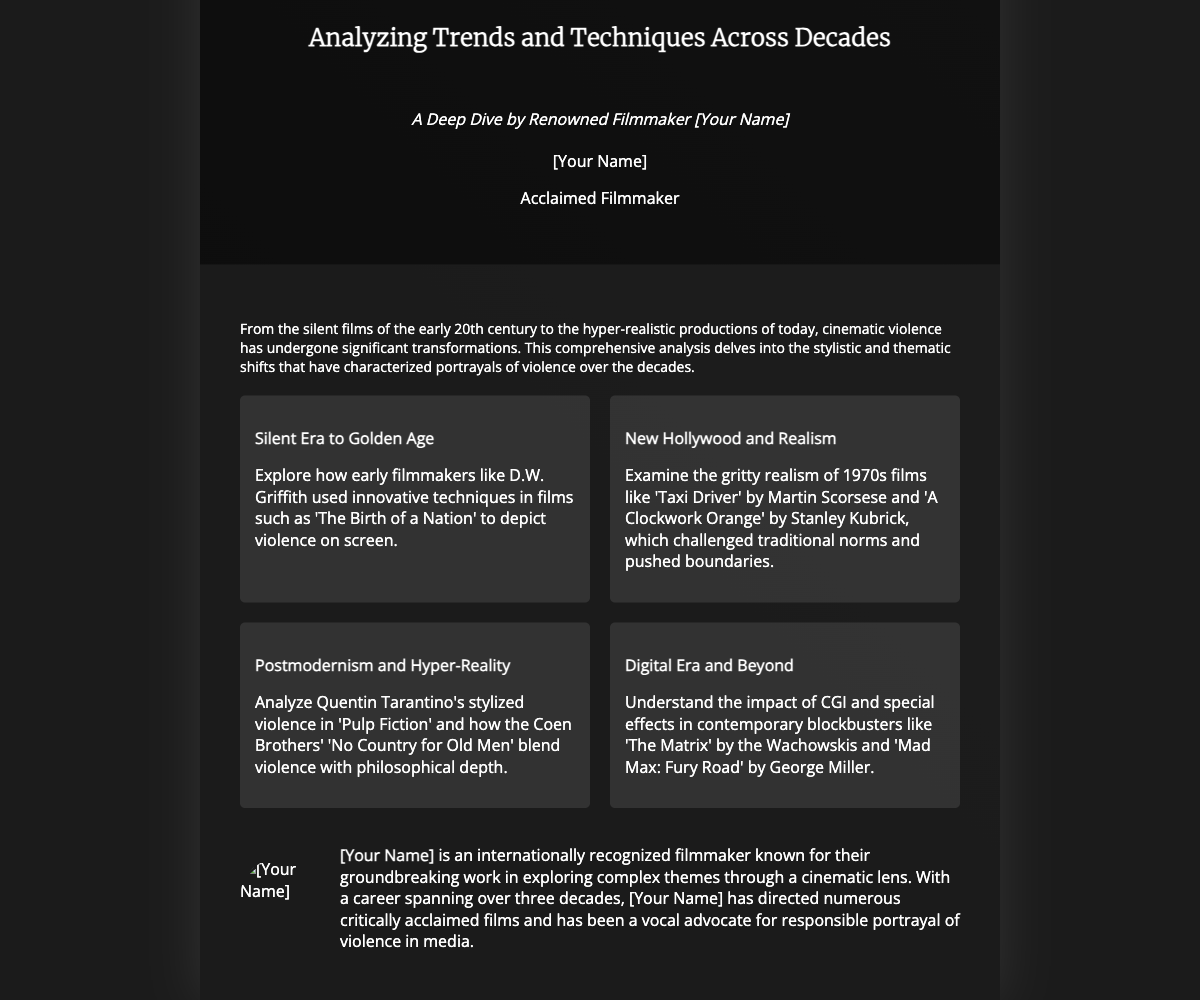What is the main title of the book? The main title is prominently displayed at the top of the front cover of the book.
Answer: The Evolution of Cinematic Violence Who is the author of the book? The author's name is listed in the front cover area, indicating who wrote the analysis.
Answer: [Your Name] What is the subtitle of the book? The subtitle is located just below the main title and provides additional context about the book's content.
Answer: Analyzing Trends and Techniques Across Decades What is one key point discussed in the book? The key points outline significant topics the book covers, detailing the evolution of cinematic violence.
Answer: Silent Era to Golden Age What decade is associated with the film 'Taxi Driver'? This film is mentioned as a representative of the gritty realism trend in 1970s cinema.
Answer: 1970s What technique is highlighted in the 'Digital Era and Beyond' key point? The key point discusses a specific technological advancement in filmmaking that affects portrayals of violence.
Answer: CGI What genre do the mentioned films like 'Pulp Fiction' and 'No Country for Old Men' belong to? These films are analyzed in the context of their unique approach to violence and storytelling.
Answer: Postmodernism How many decades of cinematic violence are analyzed in this book? The book discusses the transformation of cinematic violence over multiple decades.
Answer: Four What thematic shift does the book start analyzing from the silent films? The book initiates its analysis starting from the early cinematic practices, leading to later developments.
Answer: Stylistic and thematic shifts 